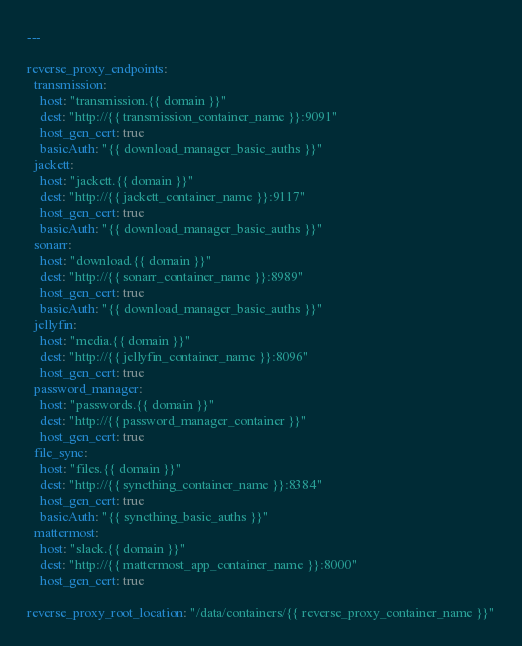Convert code to text. <code><loc_0><loc_0><loc_500><loc_500><_YAML_>---

reverse_proxy_endpoints:
  transmission:
    host: "transmission.{{ domain }}"
    dest: "http://{{ transmission_container_name }}:9091"
    host_gen_cert: true
    basicAuth: "{{ download_manager_basic_auths }}"
  jackett:
    host: "jackett.{{ domain }}"
    dest: "http://{{ jackett_container_name }}:9117"
    host_gen_cert: true
    basicAuth: "{{ download_manager_basic_auths }}"
  sonarr:
    host: "download.{{ domain }}"
    dest: "http://{{ sonarr_container_name }}:8989"
    host_gen_cert: true
    basicAuth: "{{ download_manager_basic_auths }}"
  jellyfin:
    host: "media.{{ domain }}"
    dest: "http://{{ jellyfin_container_name }}:8096"
    host_gen_cert: true
  password_manager:
    host: "passwords.{{ domain }}"
    dest: "http://{{ password_manager_container }}"
    host_gen_cert: true
  file_sync:
    host: "files.{{ domain }}"
    dest: "http://{{ syncthing_container_name }}:8384"
    host_gen_cert: true
    basicAuth: "{{ syncthing_basic_auths }}"
  mattermost:
    host: "slack.{{ domain }}"
    dest: "http://{{ mattermost_app_container_name }}:8000"
    host_gen_cert: true

reverse_proxy_root_location: "/data/containers/{{ reverse_proxy_container_name }}"
</code> 